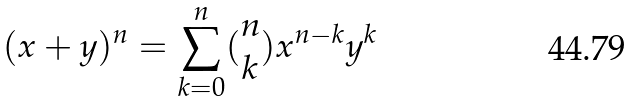<formula> <loc_0><loc_0><loc_500><loc_500>( x + y ) ^ { n } = \sum _ { k = 0 } ^ { n } ( \begin{matrix} n \\ k \end{matrix} ) x ^ { n - k } y ^ { k }</formula> 